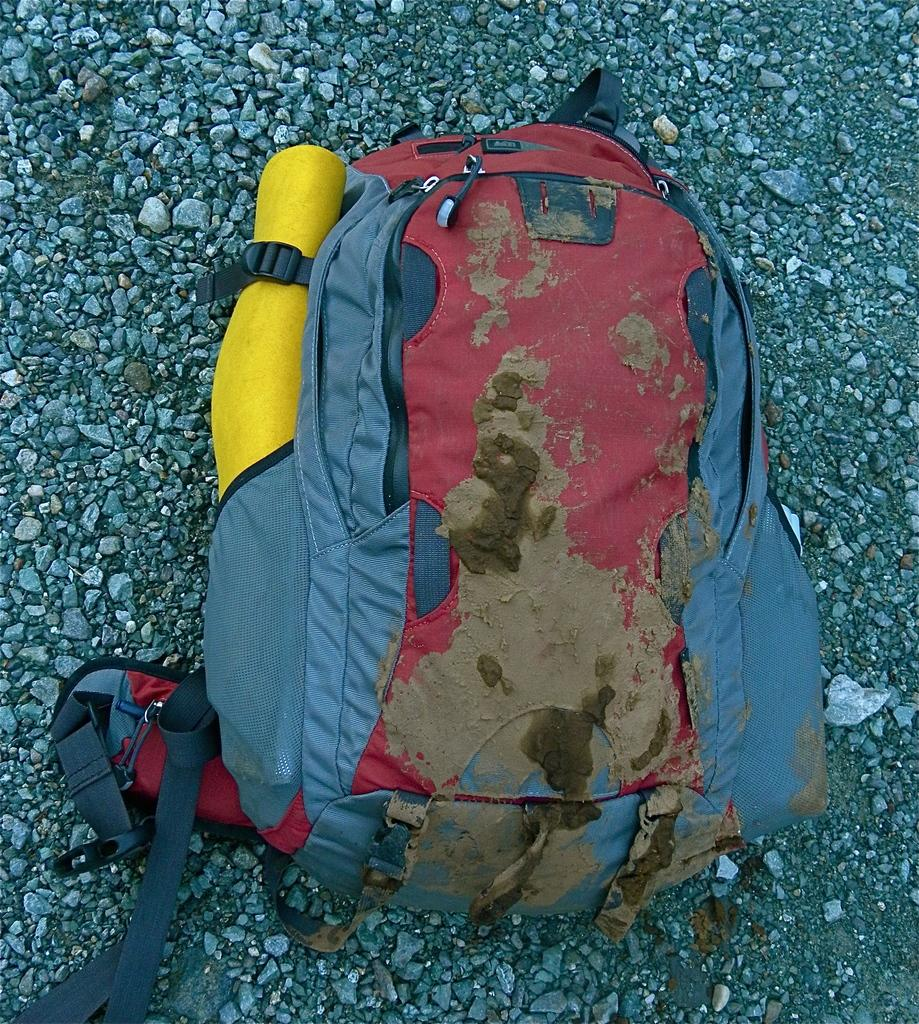What color is the backpack in the image? The backpack in the image is gray-colored. Where is the backpack located in the image? The backpack is on the floor in the image. What else can be seen on the floor in the image? There are stones on the floor in the image. Can you tell me how many parents are visible in the image? There are no parents visible in the image; it only features a gray-colored backpack and stones on the floor. 